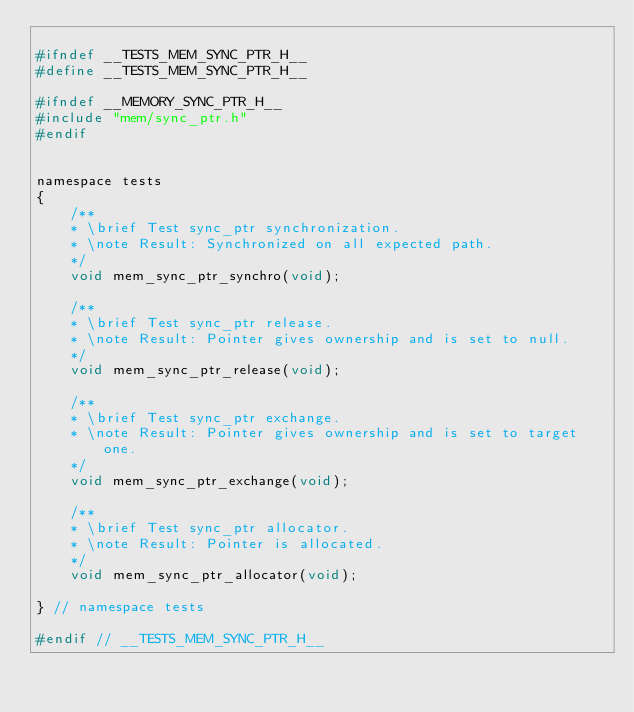<code> <loc_0><loc_0><loc_500><loc_500><_C_>
#ifndef __TESTS_MEM_SYNC_PTR_H__
#define __TESTS_MEM_SYNC_PTR_H__

#ifndef __MEMORY_SYNC_PTR_H__
#include "mem/sync_ptr.h"
#endif


namespace tests
{
    /**
    * \brief Test sync_ptr synchronization.
    * \note Result: Synchronized on all expected path.
    */
    void mem_sync_ptr_synchro(void);

    /**
    * \brief Test sync_ptr release.
    * \note Result: Pointer gives ownership and is set to null.
    */
    void mem_sync_ptr_release(void);

    /**
    * \brief Test sync_ptr exchange.
    * \note Result: Pointer gives ownership and is set to target one.
    */
    void mem_sync_ptr_exchange(void);

    /**
    * \brief Test sync_ptr allocator.
    * \note Result: Pointer is allocated.
    */
    void mem_sync_ptr_allocator(void);

} // namespace tests

#endif // __TESTS_MEM_SYNC_PTR_H__
</code> 